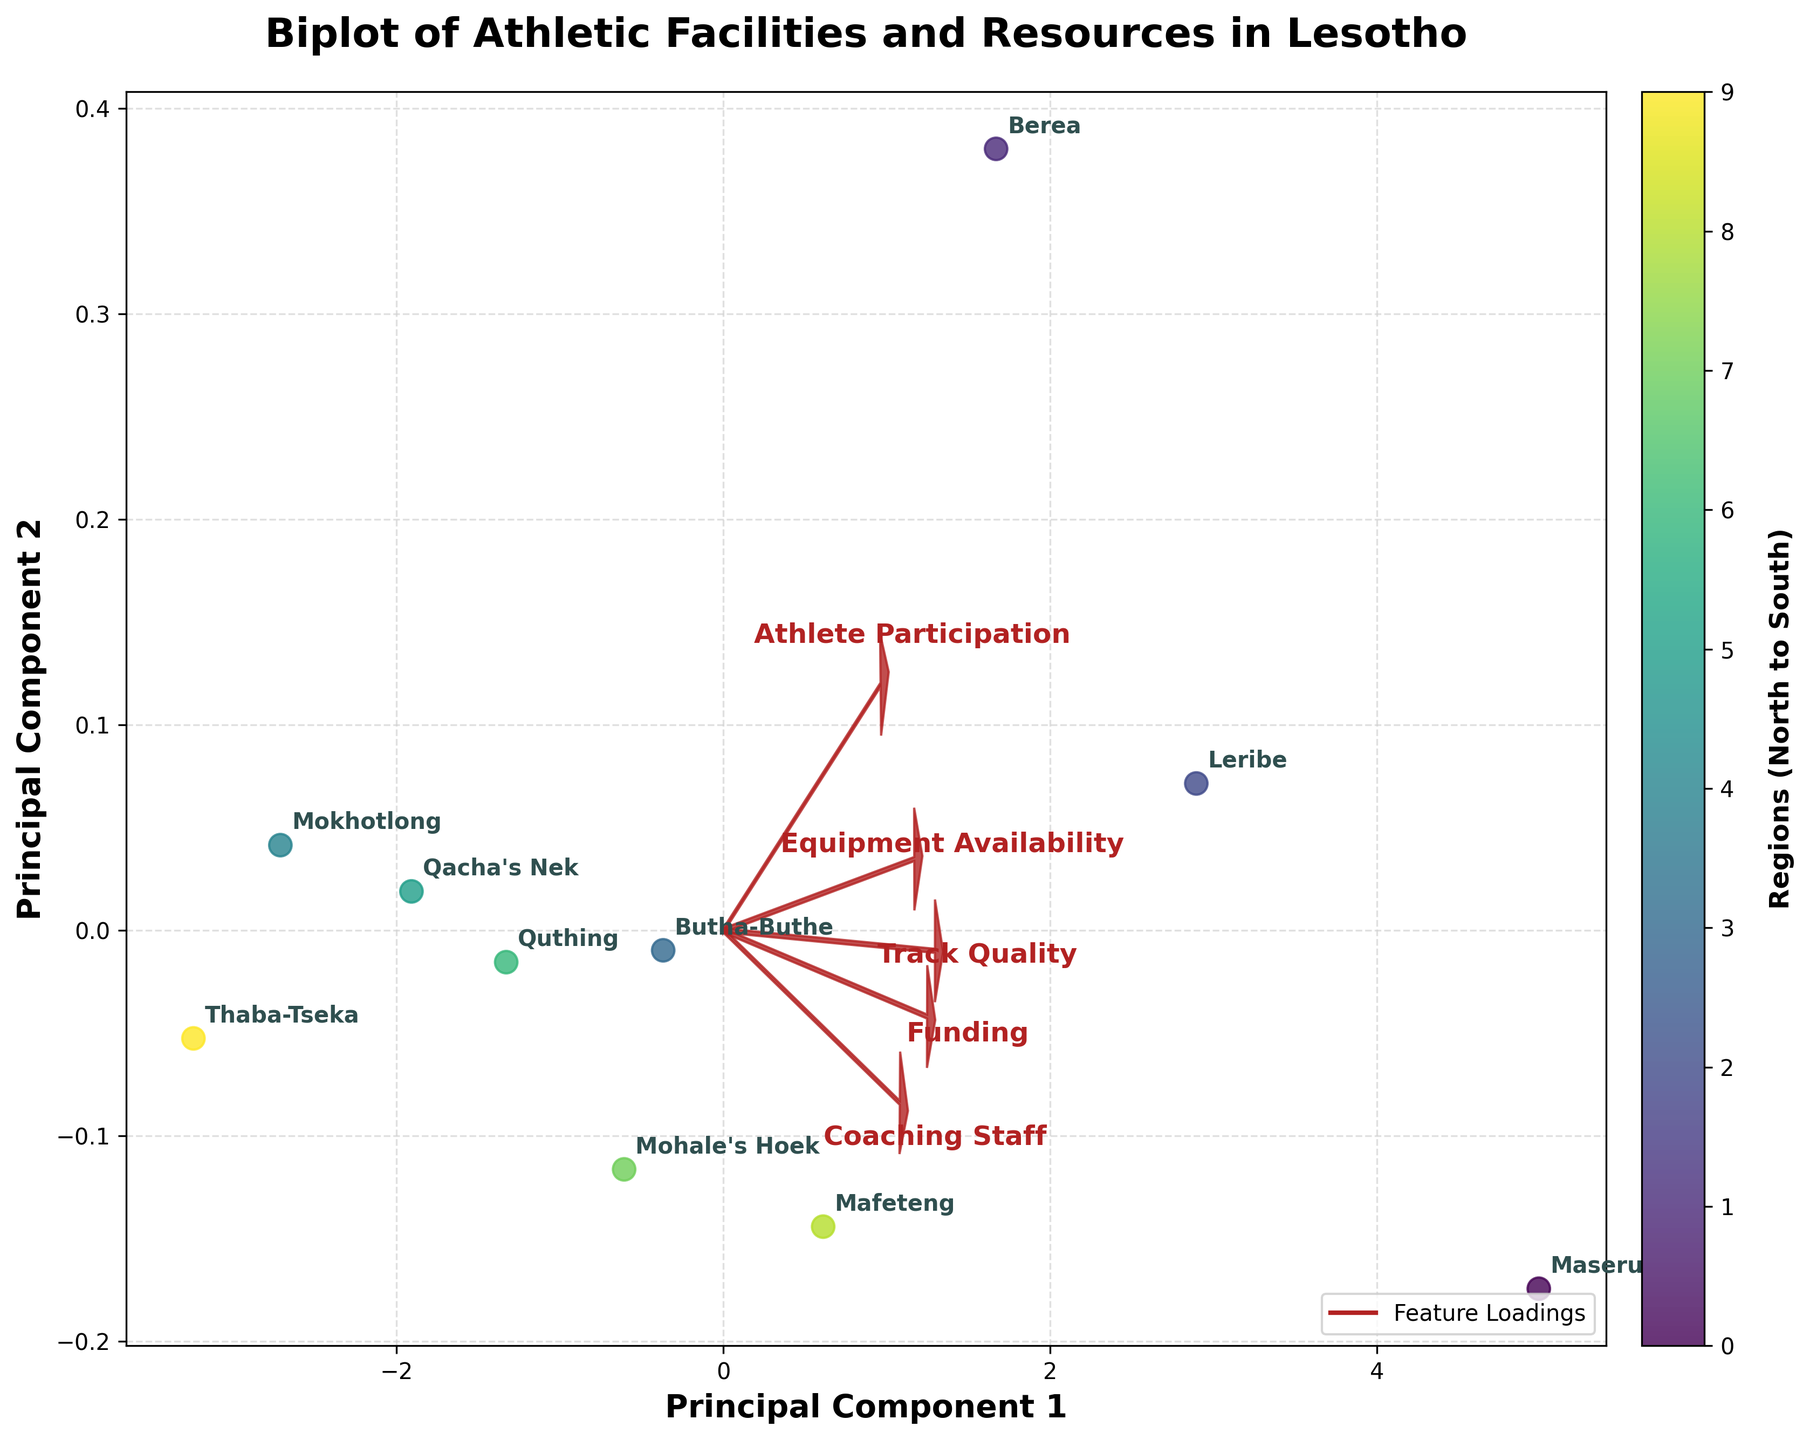What's the title of the figure? The title of the figure is clearly shown at the top of the plot. Print texts on a plot are usually large and easy to locate.
Answer: Biplot of Athletic Facilities and Resources in Lesotho What do the X and Y axes represent in this biplot? The axes labels provide the necessary information. The label on the X axis is "Principal Component 1" and on the Y axis is "Principal Component 2".
Answer: Principal Component 1 and Principal Component 2 How many regions are represented in the biplot? The biplot has points labelled by region names, and by counting them, you can see that each point represents a different region. Counting these labels gives a total of 10 regions.
Answer: 10 Which region appears to have a balance of all features? The region that is positioned close to the origin, indicating it doesn't have extreme values in any direction, is the one with a balance of all features. Maseru is very close to the origin, while others are more spread out.
Answer: Maseru How does Berea compare to Maseru in terms of feature loadings? Berea is plotted further from the origin compared to Maseru and is along vectors pointing towards higher values of "Athlete Participation" and "Track Quality". This means Berea has lower loadings in these features compared to Maseru.
Answer: Berea has lower loadings in some features than Maseru Which features are indicated by the arrows in the biplot? The ends of the arrows have labels indicating different features. There are five arrows, each labeled "Track Quality", "Equipment Availability", "Coaching Staff", "Funding", and "Athlete Participation".
Answer: Track Quality, Equipment Availability, Coaching Staff, Funding, Athlete Participation What can be inferred about Thaba-Tseka based on its position on the biplot? Thaba-Tseka is positioned far from the origin towards the lower range of both principal components. This suggests it has low values in most features compared to other regions.
Answer: Low values in most features Which features contribute most to the variance in Principal Component 1? The arrows representing the features help in identifying this, as the length of the arrows and their proximity to the Principal Component 1 axis show higher contributions. "Coaching Staff" and "Equipment Availability" have significant loadings on Principal Component 1 given their notable directions and magnitudes.
Answer: Coaching Staff and Equipment Availability Is there a region that stands out for having better resources overall? Checking the regions' scatter positions, Maseru stands out as it is relatively well-balanced and closer to higher loadings on several features, making it appear to have better resources overall.
Answer: Maseru 